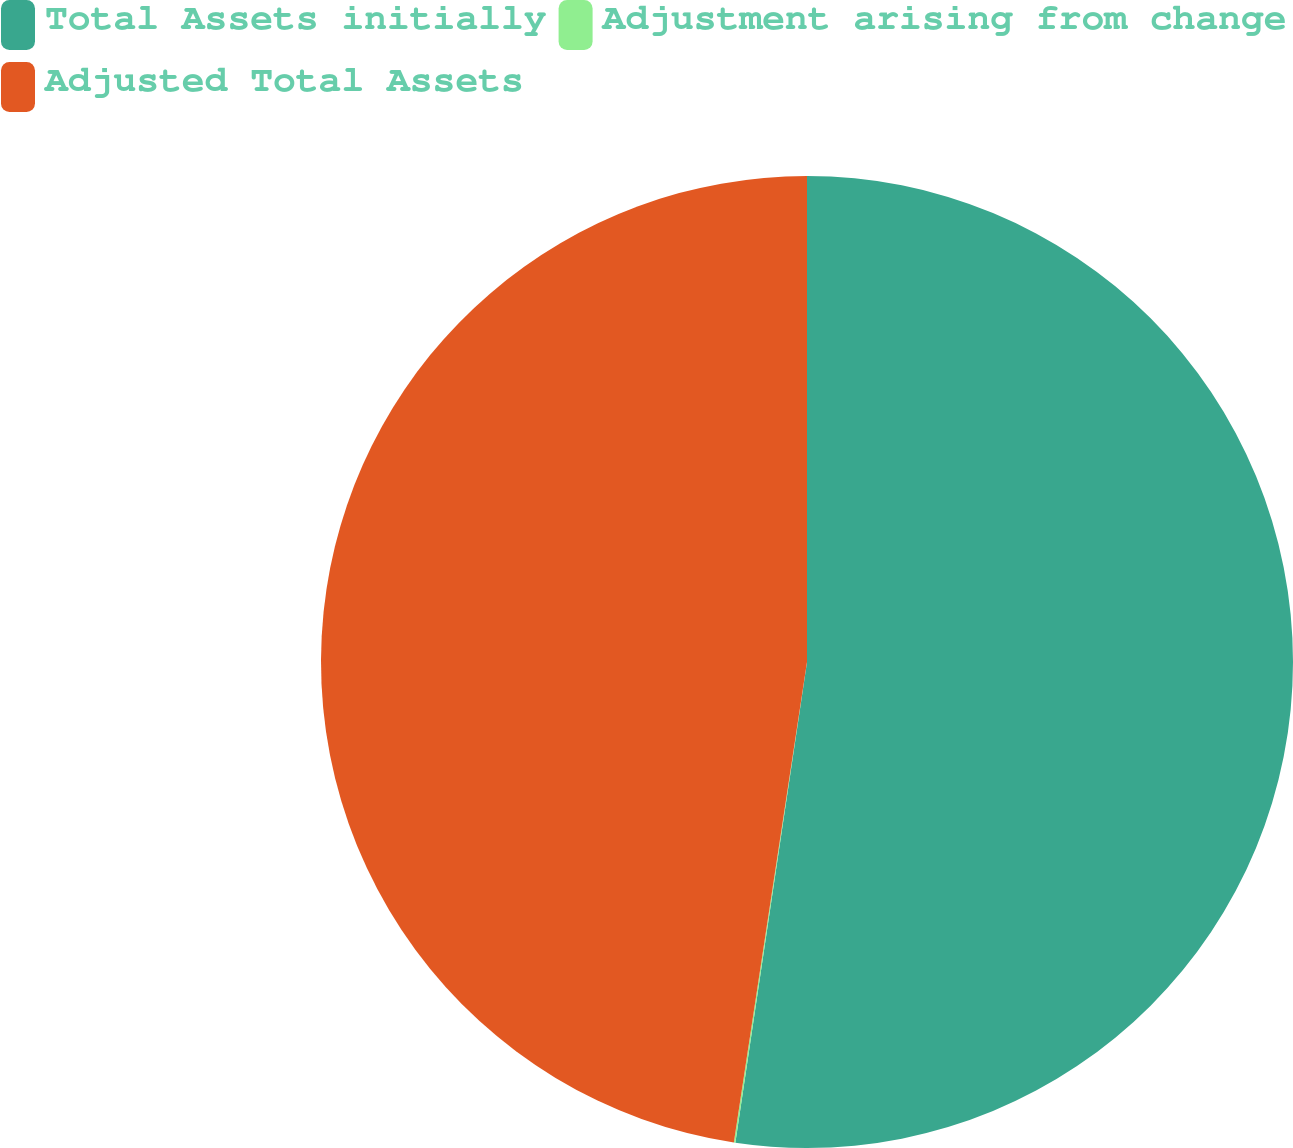Convert chart. <chart><loc_0><loc_0><loc_500><loc_500><pie_chart><fcel>Total Assets initially<fcel>Adjustment arising from change<fcel>Adjusted Total Assets<nl><fcel>52.36%<fcel>0.05%<fcel>47.6%<nl></chart> 